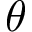Convert formula to latex. <formula><loc_0><loc_0><loc_500><loc_500>\theta</formula> 